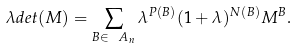<formula> <loc_0><loc_0><loc_500><loc_500>\lambda d e t ( M ) = \sum _ { B \in \ A _ { n } } \lambda ^ { P ( B ) } ( 1 + \lambda ) ^ { N ( B ) } M ^ { B } .</formula> 